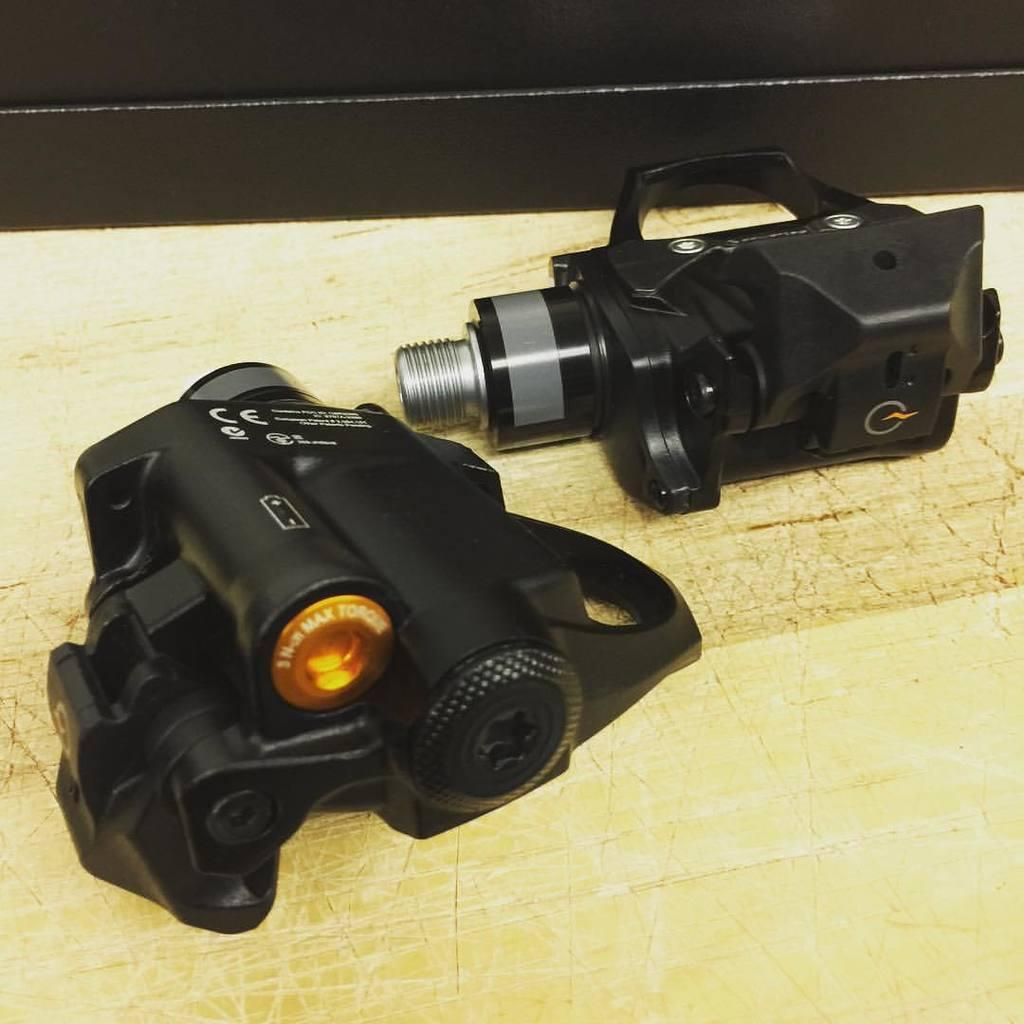What object is the main focus of the image? There is a camera in the image. Where is the camera located? The camera is placed on a desk. What type of story is being told by the leaf in the image? There is no leaf present in the image, so no story can be told by a leaf. 